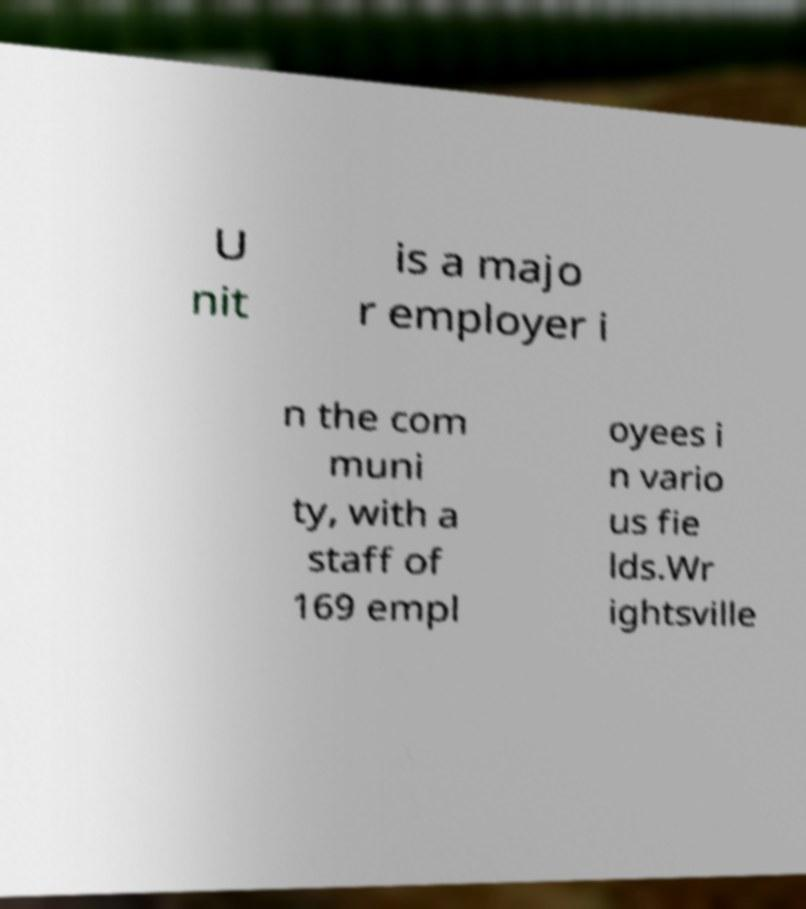Could you extract and type out the text from this image? U nit is a majo r employer i n the com muni ty, with a staff of 169 empl oyees i n vario us fie lds.Wr ightsville 